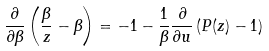Convert formula to latex. <formula><loc_0><loc_0><loc_500><loc_500>\frac { \partial } { \partial \beta } \left ( \frac { \beta } { z } - \beta \right ) = - 1 - \frac { 1 } { \beta } \frac { \partial } { \partial u } \left ( P ( z ) - 1 \right )</formula> 